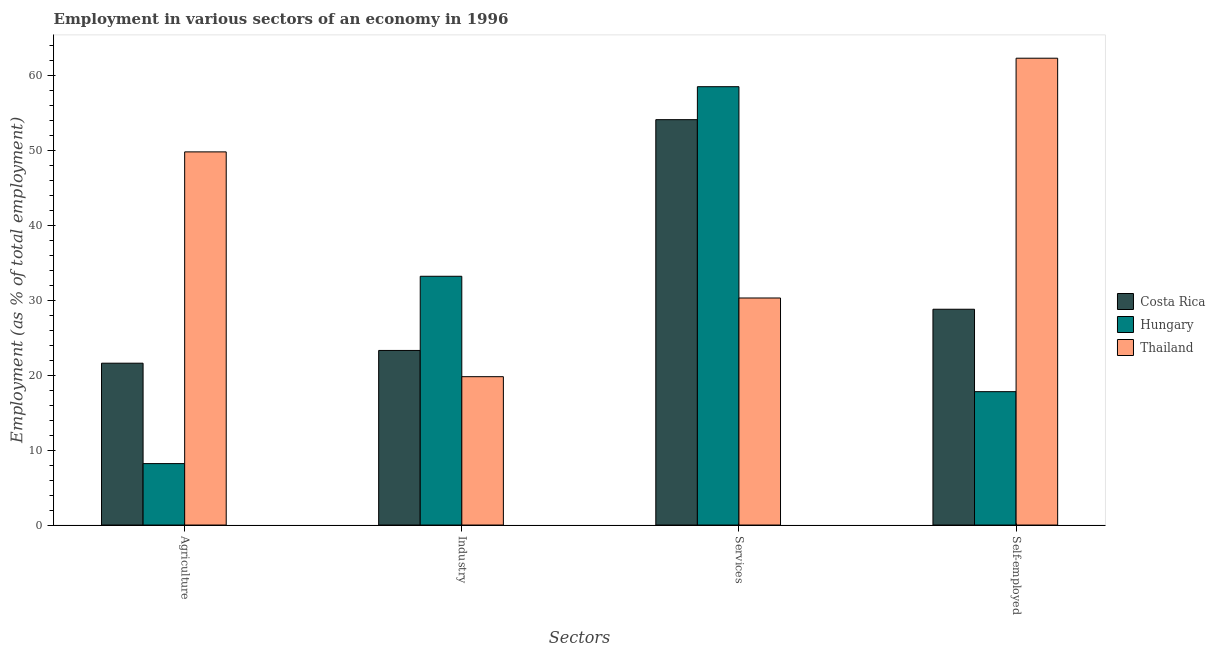How many different coloured bars are there?
Keep it short and to the point. 3. How many groups of bars are there?
Give a very brief answer. 4. Are the number of bars on each tick of the X-axis equal?
Provide a short and direct response. Yes. How many bars are there on the 2nd tick from the left?
Your answer should be compact. 3. What is the label of the 1st group of bars from the left?
Provide a short and direct response. Agriculture. What is the percentage of workers in industry in Thailand?
Your answer should be very brief. 19.8. Across all countries, what is the maximum percentage of workers in services?
Make the answer very short. 58.5. Across all countries, what is the minimum percentage of workers in industry?
Ensure brevity in your answer.  19.8. In which country was the percentage of workers in industry maximum?
Make the answer very short. Hungary. In which country was the percentage of workers in industry minimum?
Offer a very short reply. Thailand. What is the total percentage of workers in industry in the graph?
Keep it short and to the point. 76.3. What is the difference between the percentage of workers in services in Thailand and that in Hungary?
Provide a succinct answer. -28.2. What is the difference between the percentage of workers in services in Thailand and the percentage of workers in agriculture in Costa Rica?
Give a very brief answer. 8.7. What is the average percentage of workers in industry per country?
Keep it short and to the point. 25.43. What is the difference between the percentage of workers in industry and percentage of workers in agriculture in Thailand?
Provide a succinct answer. -30. What is the ratio of the percentage of workers in agriculture in Costa Rica to that in Thailand?
Keep it short and to the point. 0.43. What is the difference between the highest and the second highest percentage of workers in agriculture?
Your response must be concise. 28.2. What is the difference between the highest and the lowest percentage of workers in services?
Give a very brief answer. 28.2. In how many countries, is the percentage of workers in industry greater than the average percentage of workers in industry taken over all countries?
Provide a short and direct response. 1. Is it the case that in every country, the sum of the percentage of workers in industry and percentage of workers in agriculture is greater than the sum of percentage of workers in services and percentage of self employed workers?
Ensure brevity in your answer.  No. What does the 2nd bar from the right in Services represents?
Keep it short and to the point. Hungary. Is it the case that in every country, the sum of the percentage of workers in agriculture and percentage of workers in industry is greater than the percentage of workers in services?
Provide a succinct answer. No. How many countries are there in the graph?
Offer a terse response. 3. What is the difference between two consecutive major ticks on the Y-axis?
Offer a terse response. 10. Does the graph contain any zero values?
Provide a short and direct response. No. Does the graph contain grids?
Provide a short and direct response. No. Where does the legend appear in the graph?
Give a very brief answer. Center right. How many legend labels are there?
Ensure brevity in your answer.  3. How are the legend labels stacked?
Give a very brief answer. Vertical. What is the title of the graph?
Offer a very short reply. Employment in various sectors of an economy in 1996. Does "South Africa" appear as one of the legend labels in the graph?
Provide a succinct answer. No. What is the label or title of the X-axis?
Keep it short and to the point. Sectors. What is the label or title of the Y-axis?
Offer a terse response. Employment (as % of total employment). What is the Employment (as % of total employment) of Costa Rica in Agriculture?
Offer a very short reply. 21.6. What is the Employment (as % of total employment) of Hungary in Agriculture?
Your answer should be compact. 8.2. What is the Employment (as % of total employment) in Thailand in Agriculture?
Provide a short and direct response. 49.8. What is the Employment (as % of total employment) in Costa Rica in Industry?
Offer a terse response. 23.3. What is the Employment (as % of total employment) in Hungary in Industry?
Provide a short and direct response. 33.2. What is the Employment (as % of total employment) of Thailand in Industry?
Your answer should be very brief. 19.8. What is the Employment (as % of total employment) of Costa Rica in Services?
Offer a very short reply. 54.1. What is the Employment (as % of total employment) in Hungary in Services?
Your answer should be compact. 58.5. What is the Employment (as % of total employment) in Thailand in Services?
Make the answer very short. 30.3. What is the Employment (as % of total employment) of Costa Rica in Self-employed?
Make the answer very short. 28.8. What is the Employment (as % of total employment) in Hungary in Self-employed?
Keep it short and to the point. 17.8. What is the Employment (as % of total employment) of Thailand in Self-employed?
Provide a succinct answer. 62.3. Across all Sectors, what is the maximum Employment (as % of total employment) in Costa Rica?
Keep it short and to the point. 54.1. Across all Sectors, what is the maximum Employment (as % of total employment) in Hungary?
Your answer should be compact. 58.5. Across all Sectors, what is the maximum Employment (as % of total employment) in Thailand?
Your answer should be compact. 62.3. Across all Sectors, what is the minimum Employment (as % of total employment) of Costa Rica?
Your answer should be very brief. 21.6. Across all Sectors, what is the minimum Employment (as % of total employment) in Hungary?
Keep it short and to the point. 8.2. Across all Sectors, what is the minimum Employment (as % of total employment) in Thailand?
Make the answer very short. 19.8. What is the total Employment (as % of total employment) of Costa Rica in the graph?
Your answer should be very brief. 127.8. What is the total Employment (as % of total employment) of Hungary in the graph?
Your answer should be compact. 117.7. What is the total Employment (as % of total employment) in Thailand in the graph?
Make the answer very short. 162.2. What is the difference between the Employment (as % of total employment) in Costa Rica in Agriculture and that in Services?
Keep it short and to the point. -32.5. What is the difference between the Employment (as % of total employment) of Hungary in Agriculture and that in Services?
Give a very brief answer. -50.3. What is the difference between the Employment (as % of total employment) in Hungary in Agriculture and that in Self-employed?
Make the answer very short. -9.6. What is the difference between the Employment (as % of total employment) in Thailand in Agriculture and that in Self-employed?
Offer a terse response. -12.5. What is the difference between the Employment (as % of total employment) of Costa Rica in Industry and that in Services?
Provide a short and direct response. -30.8. What is the difference between the Employment (as % of total employment) of Hungary in Industry and that in Services?
Offer a terse response. -25.3. What is the difference between the Employment (as % of total employment) of Thailand in Industry and that in Self-employed?
Keep it short and to the point. -42.5. What is the difference between the Employment (as % of total employment) of Costa Rica in Services and that in Self-employed?
Your answer should be compact. 25.3. What is the difference between the Employment (as % of total employment) in Hungary in Services and that in Self-employed?
Your answer should be very brief. 40.7. What is the difference between the Employment (as % of total employment) of Thailand in Services and that in Self-employed?
Ensure brevity in your answer.  -32. What is the difference between the Employment (as % of total employment) in Costa Rica in Agriculture and the Employment (as % of total employment) in Thailand in Industry?
Offer a terse response. 1.8. What is the difference between the Employment (as % of total employment) of Hungary in Agriculture and the Employment (as % of total employment) of Thailand in Industry?
Offer a very short reply. -11.6. What is the difference between the Employment (as % of total employment) of Costa Rica in Agriculture and the Employment (as % of total employment) of Hungary in Services?
Provide a succinct answer. -36.9. What is the difference between the Employment (as % of total employment) of Costa Rica in Agriculture and the Employment (as % of total employment) of Thailand in Services?
Your answer should be very brief. -8.7. What is the difference between the Employment (as % of total employment) of Hungary in Agriculture and the Employment (as % of total employment) of Thailand in Services?
Provide a short and direct response. -22.1. What is the difference between the Employment (as % of total employment) in Costa Rica in Agriculture and the Employment (as % of total employment) in Thailand in Self-employed?
Keep it short and to the point. -40.7. What is the difference between the Employment (as % of total employment) in Hungary in Agriculture and the Employment (as % of total employment) in Thailand in Self-employed?
Your answer should be compact. -54.1. What is the difference between the Employment (as % of total employment) of Costa Rica in Industry and the Employment (as % of total employment) of Hungary in Services?
Offer a terse response. -35.2. What is the difference between the Employment (as % of total employment) of Costa Rica in Industry and the Employment (as % of total employment) of Thailand in Services?
Make the answer very short. -7. What is the difference between the Employment (as % of total employment) in Hungary in Industry and the Employment (as % of total employment) in Thailand in Services?
Give a very brief answer. 2.9. What is the difference between the Employment (as % of total employment) in Costa Rica in Industry and the Employment (as % of total employment) in Thailand in Self-employed?
Provide a succinct answer. -39. What is the difference between the Employment (as % of total employment) in Hungary in Industry and the Employment (as % of total employment) in Thailand in Self-employed?
Provide a succinct answer. -29.1. What is the difference between the Employment (as % of total employment) of Costa Rica in Services and the Employment (as % of total employment) of Hungary in Self-employed?
Offer a terse response. 36.3. What is the difference between the Employment (as % of total employment) of Costa Rica in Services and the Employment (as % of total employment) of Thailand in Self-employed?
Make the answer very short. -8.2. What is the difference between the Employment (as % of total employment) in Hungary in Services and the Employment (as % of total employment) in Thailand in Self-employed?
Your response must be concise. -3.8. What is the average Employment (as % of total employment) of Costa Rica per Sectors?
Offer a terse response. 31.95. What is the average Employment (as % of total employment) of Hungary per Sectors?
Provide a short and direct response. 29.43. What is the average Employment (as % of total employment) in Thailand per Sectors?
Offer a terse response. 40.55. What is the difference between the Employment (as % of total employment) in Costa Rica and Employment (as % of total employment) in Thailand in Agriculture?
Provide a succinct answer. -28.2. What is the difference between the Employment (as % of total employment) of Hungary and Employment (as % of total employment) of Thailand in Agriculture?
Make the answer very short. -41.6. What is the difference between the Employment (as % of total employment) of Costa Rica and Employment (as % of total employment) of Hungary in Industry?
Your response must be concise. -9.9. What is the difference between the Employment (as % of total employment) in Hungary and Employment (as % of total employment) in Thailand in Industry?
Your answer should be compact. 13.4. What is the difference between the Employment (as % of total employment) in Costa Rica and Employment (as % of total employment) in Thailand in Services?
Your answer should be very brief. 23.8. What is the difference between the Employment (as % of total employment) of Hungary and Employment (as % of total employment) of Thailand in Services?
Make the answer very short. 28.2. What is the difference between the Employment (as % of total employment) of Costa Rica and Employment (as % of total employment) of Thailand in Self-employed?
Your answer should be very brief. -33.5. What is the difference between the Employment (as % of total employment) in Hungary and Employment (as % of total employment) in Thailand in Self-employed?
Keep it short and to the point. -44.5. What is the ratio of the Employment (as % of total employment) of Costa Rica in Agriculture to that in Industry?
Provide a short and direct response. 0.93. What is the ratio of the Employment (as % of total employment) of Hungary in Agriculture to that in Industry?
Provide a succinct answer. 0.25. What is the ratio of the Employment (as % of total employment) of Thailand in Agriculture to that in Industry?
Your answer should be very brief. 2.52. What is the ratio of the Employment (as % of total employment) of Costa Rica in Agriculture to that in Services?
Make the answer very short. 0.4. What is the ratio of the Employment (as % of total employment) of Hungary in Agriculture to that in Services?
Provide a succinct answer. 0.14. What is the ratio of the Employment (as % of total employment) in Thailand in Agriculture to that in Services?
Give a very brief answer. 1.64. What is the ratio of the Employment (as % of total employment) of Costa Rica in Agriculture to that in Self-employed?
Your answer should be very brief. 0.75. What is the ratio of the Employment (as % of total employment) of Hungary in Agriculture to that in Self-employed?
Make the answer very short. 0.46. What is the ratio of the Employment (as % of total employment) in Thailand in Agriculture to that in Self-employed?
Give a very brief answer. 0.8. What is the ratio of the Employment (as % of total employment) of Costa Rica in Industry to that in Services?
Your answer should be very brief. 0.43. What is the ratio of the Employment (as % of total employment) of Hungary in Industry to that in Services?
Your answer should be very brief. 0.57. What is the ratio of the Employment (as % of total employment) in Thailand in Industry to that in Services?
Provide a short and direct response. 0.65. What is the ratio of the Employment (as % of total employment) in Costa Rica in Industry to that in Self-employed?
Your response must be concise. 0.81. What is the ratio of the Employment (as % of total employment) of Hungary in Industry to that in Self-employed?
Offer a terse response. 1.87. What is the ratio of the Employment (as % of total employment) in Thailand in Industry to that in Self-employed?
Keep it short and to the point. 0.32. What is the ratio of the Employment (as % of total employment) of Costa Rica in Services to that in Self-employed?
Offer a terse response. 1.88. What is the ratio of the Employment (as % of total employment) of Hungary in Services to that in Self-employed?
Offer a terse response. 3.29. What is the ratio of the Employment (as % of total employment) in Thailand in Services to that in Self-employed?
Provide a short and direct response. 0.49. What is the difference between the highest and the second highest Employment (as % of total employment) in Costa Rica?
Offer a very short reply. 25.3. What is the difference between the highest and the second highest Employment (as % of total employment) in Hungary?
Provide a succinct answer. 25.3. What is the difference between the highest and the lowest Employment (as % of total employment) in Costa Rica?
Give a very brief answer. 32.5. What is the difference between the highest and the lowest Employment (as % of total employment) of Hungary?
Offer a terse response. 50.3. What is the difference between the highest and the lowest Employment (as % of total employment) of Thailand?
Provide a succinct answer. 42.5. 